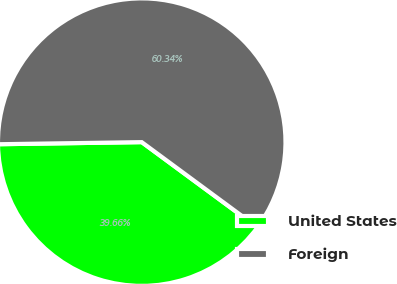<chart> <loc_0><loc_0><loc_500><loc_500><pie_chart><fcel>United States<fcel>Foreign<nl><fcel>39.66%<fcel>60.34%<nl></chart> 